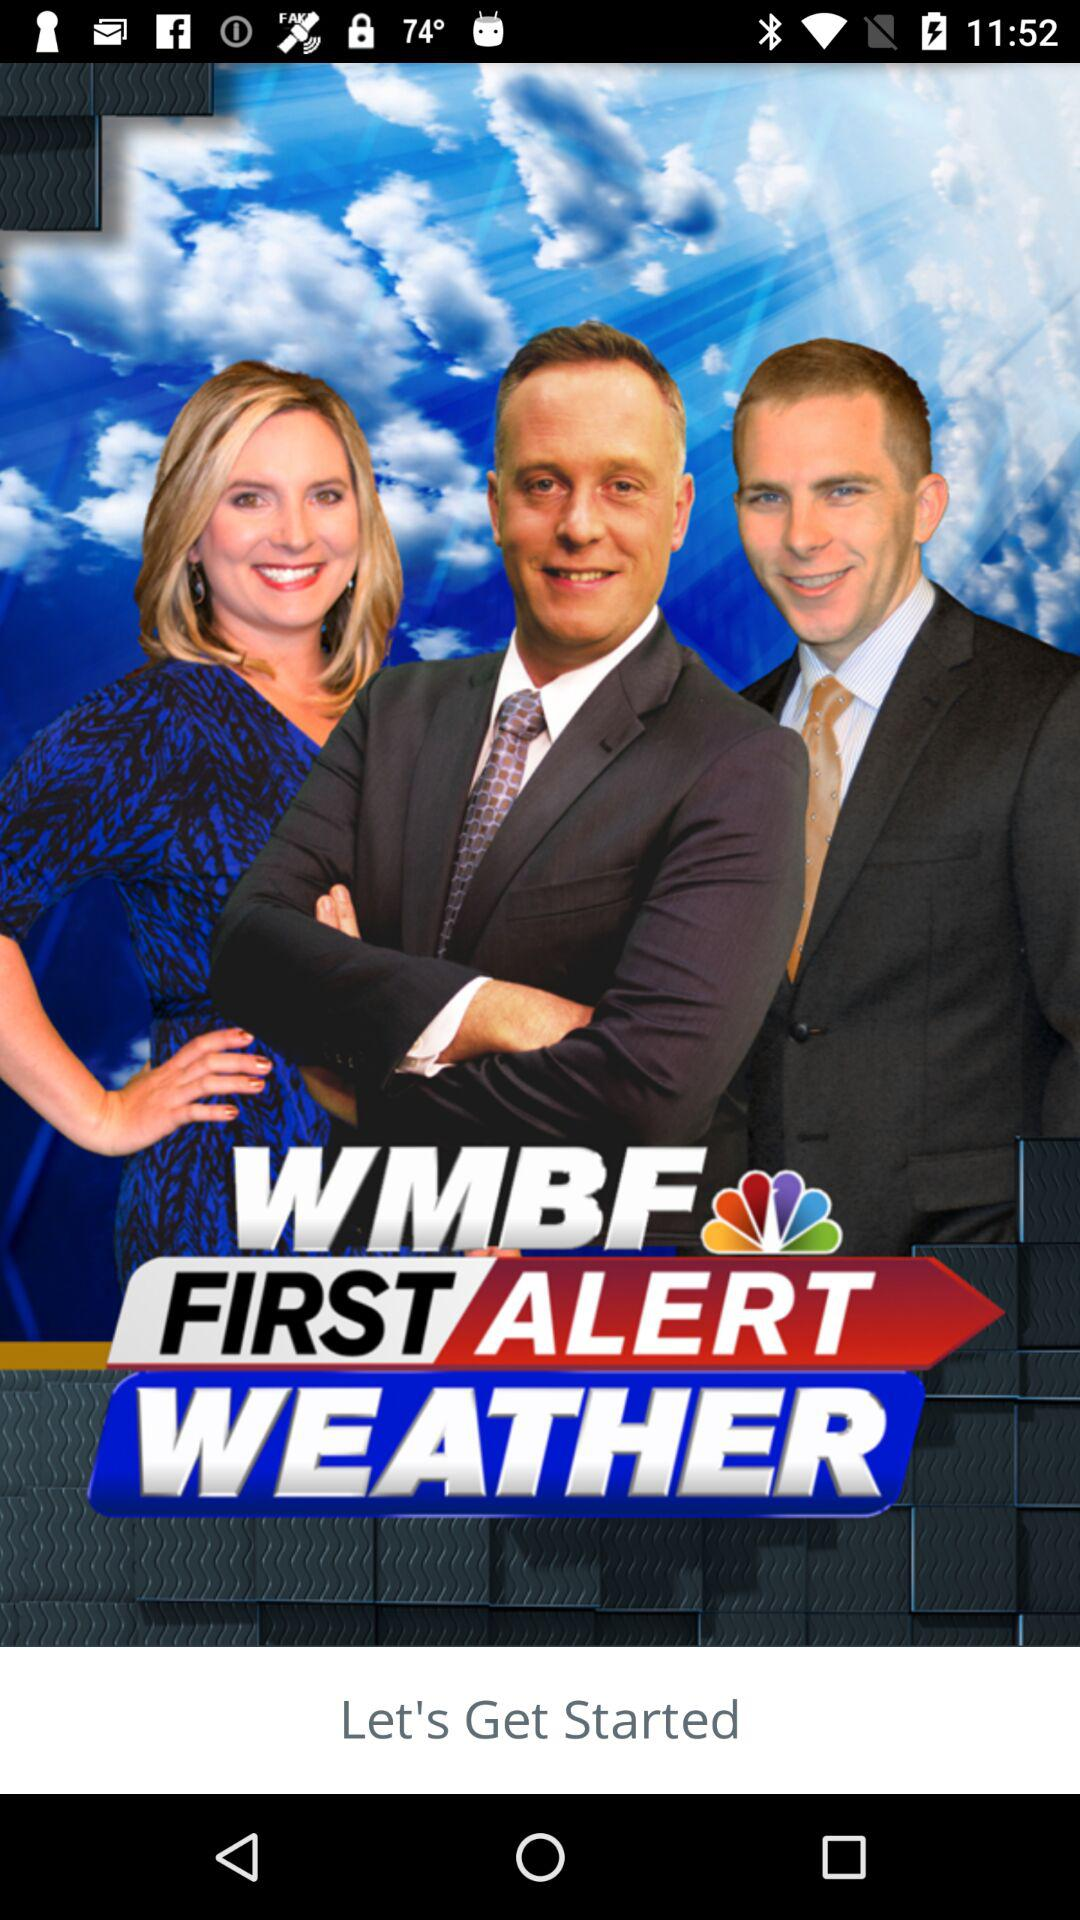What is the name of the application? The name of the application is "WMBF FIRST ALERT WEATHER". 